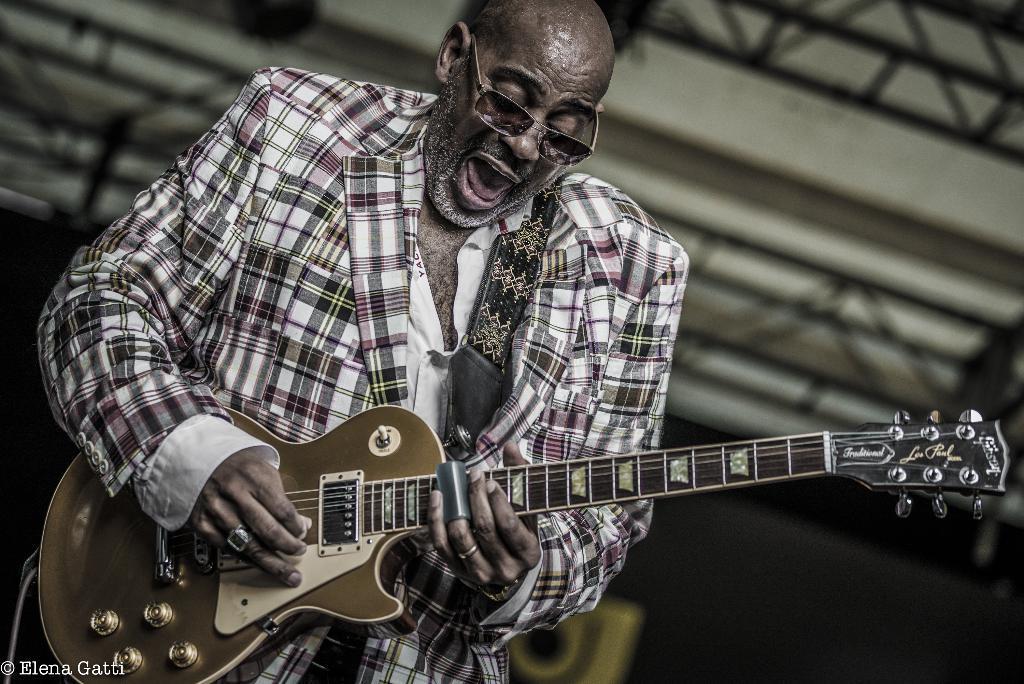Please provide a concise description of this image. This image consists of a man who is holding a guitar in his hand. He is wearing specs and he is singing something. 